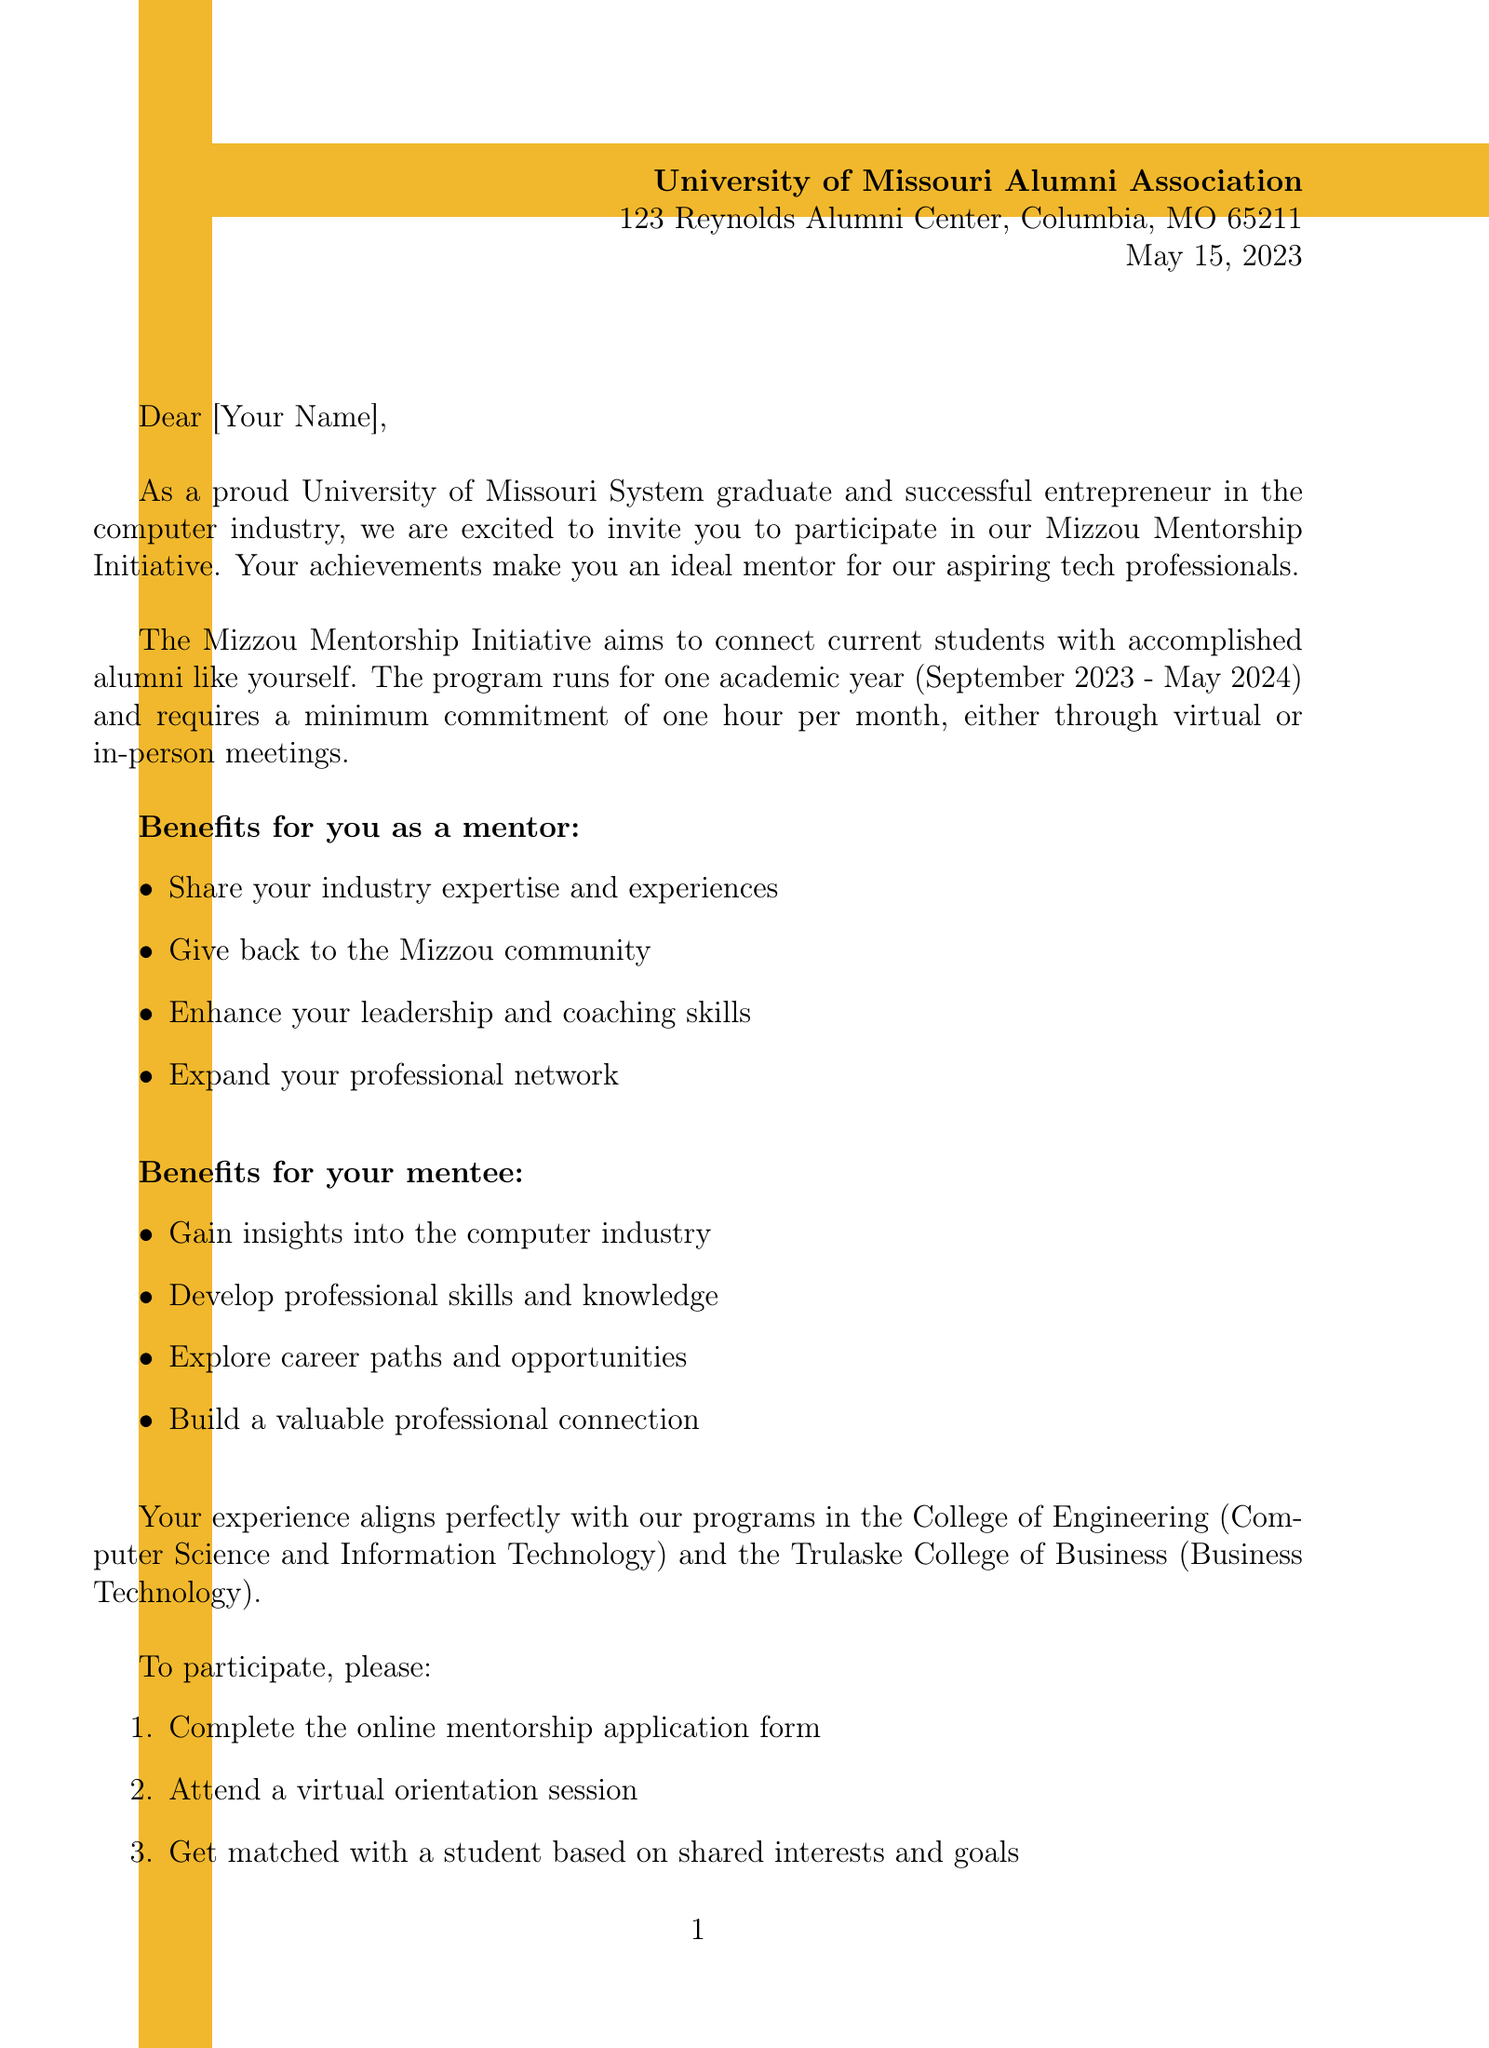What is the name of the mentorship program? The document explicitly mentions the program name as the Mizzou Mentorship Initiative.
Answer: Mizzou Mentorship Initiative Who is the program coordinator? The letter provides the name and contact details of the program coordinator, which is Emily Roberts.
Answer: Emily Roberts What is the duration of the mentorship program? The duration is specified in the document as one academic year, from September 2023 to May 2024.
Answer: One academic year (September 2023 - May 2024) What is the minimum commitment required from a mentor? The letter states the minimum commitment is one hour per month from the mentor.
Answer: One hour per month What are the benefits for the mentee? The document lists multiple benefits for mentees, including gaining insights into the computer industry.
Answer: Gain insights into the computer industry Which college offers the Computer Science program? The letter refers to the College of Engineering as the college offering the Computer Science program.
Answer: College of Engineering What is the first step to participate in the program? The document outlines the participation process starting with completing the online mentorship application form.
Answer: Complete the online mentorship application form How can interested mentors contact the program coordinator? The letter provides the email address and phone number of the program coordinator for any inquiries.
Answer: mizzoumentorship@missouri.edu or (573) 882-6514 